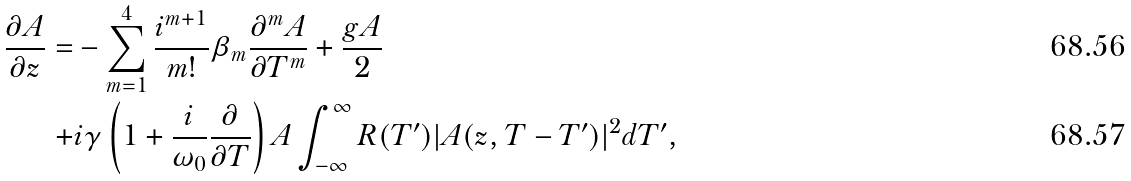<formula> <loc_0><loc_0><loc_500><loc_500>\frac { \partial A } { \partial z } = & - \sum _ { m = 1 } ^ { 4 } \frac { i ^ { m + 1 } } { m ! } \beta _ { m } \frac { \partial ^ { m } A } { \partial T ^ { m } } + \frac { g A } { 2 } \\ + & i \gamma \left ( 1 + \frac { i } { \omega _ { 0 } } \frac { \partial } { \partial T } \right ) A \int _ { - \infty } ^ { \infty } R ( T ^ { \prime } ) | A ( z , T - T ^ { \prime } ) | ^ { 2 } d T ^ { \prime } ,</formula> 